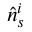<formula> <loc_0><loc_0><loc_500><loc_500>\hat { n } _ { s } ^ { i }</formula> 